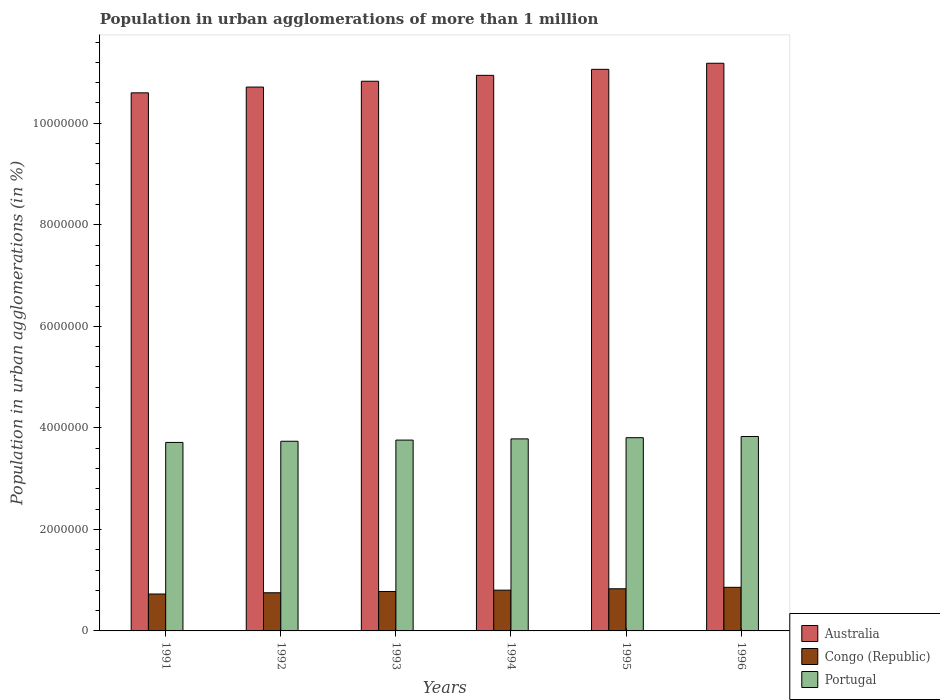How many different coloured bars are there?
Ensure brevity in your answer.  3. Are the number of bars per tick equal to the number of legend labels?
Offer a terse response. Yes. How many bars are there on the 3rd tick from the left?
Your answer should be very brief. 3. What is the label of the 4th group of bars from the left?
Offer a very short reply. 1994. In how many cases, is the number of bars for a given year not equal to the number of legend labels?
Give a very brief answer. 0. What is the population in urban agglomerations in Portugal in 1996?
Offer a terse response. 3.83e+06. Across all years, what is the maximum population in urban agglomerations in Portugal?
Provide a succinct answer. 3.83e+06. Across all years, what is the minimum population in urban agglomerations in Australia?
Provide a short and direct response. 1.06e+07. In which year was the population in urban agglomerations in Australia maximum?
Provide a succinct answer. 1996. In which year was the population in urban agglomerations in Australia minimum?
Give a very brief answer. 1991. What is the total population in urban agglomerations in Congo (Republic) in the graph?
Ensure brevity in your answer.  4.75e+06. What is the difference between the population in urban agglomerations in Australia in 1991 and that in 1992?
Offer a terse response. -1.14e+05. What is the difference between the population in urban agglomerations in Portugal in 1992 and the population in urban agglomerations in Australia in 1995?
Keep it short and to the point. -7.33e+06. What is the average population in urban agglomerations in Australia per year?
Offer a terse response. 1.09e+07. In the year 1993, what is the difference between the population in urban agglomerations in Australia and population in urban agglomerations in Congo (Republic)?
Give a very brief answer. 1.01e+07. What is the ratio of the population in urban agglomerations in Congo (Republic) in 1991 to that in 1995?
Your response must be concise. 0.88. Is the difference between the population in urban agglomerations in Australia in 1991 and 1996 greater than the difference between the population in urban agglomerations in Congo (Republic) in 1991 and 1996?
Your answer should be compact. No. What is the difference between the highest and the second highest population in urban agglomerations in Congo (Republic)?
Provide a succinct answer. 2.86e+04. What is the difference between the highest and the lowest population in urban agglomerations in Australia?
Your answer should be very brief. 5.83e+05. In how many years, is the population in urban agglomerations in Australia greater than the average population in urban agglomerations in Australia taken over all years?
Keep it short and to the point. 3. Is the sum of the population in urban agglomerations in Congo (Republic) in 1991 and 1992 greater than the maximum population in urban agglomerations in Australia across all years?
Make the answer very short. No. What does the 2nd bar from the left in 1996 represents?
Make the answer very short. Congo (Republic). What does the 2nd bar from the right in 1991 represents?
Provide a succinct answer. Congo (Republic). Are all the bars in the graph horizontal?
Provide a succinct answer. No. How many years are there in the graph?
Make the answer very short. 6. Are the values on the major ticks of Y-axis written in scientific E-notation?
Your answer should be compact. No. Does the graph contain any zero values?
Provide a succinct answer. No. Does the graph contain grids?
Your answer should be very brief. No. Where does the legend appear in the graph?
Ensure brevity in your answer.  Bottom right. How many legend labels are there?
Offer a terse response. 3. How are the legend labels stacked?
Make the answer very short. Vertical. What is the title of the graph?
Your response must be concise. Population in urban agglomerations of more than 1 million. Does "Uzbekistan" appear as one of the legend labels in the graph?
Give a very brief answer. No. What is the label or title of the X-axis?
Offer a terse response. Years. What is the label or title of the Y-axis?
Offer a terse response. Population in urban agglomerations (in %). What is the Population in urban agglomerations (in %) of Australia in 1991?
Provide a succinct answer. 1.06e+07. What is the Population in urban agglomerations (in %) in Congo (Republic) in 1991?
Your response must be concise. 7.27e+05. What is the Population in urban agglomerations (in %) of Portugal in 1991?
Offer a terse response. 3.71e+06. What is the Population in urban agglomerations (in %) in Australia in 1992?
Your answer should be very brief. 1.07e+07. What is the Population in urban agglomerations (in %) in Congo (Republic) in 1992?
Give a very brief answer. 7.52e+05. What is the Population in urban agglomerations (in %) in Portugal in 1992?
Provide a short and direct response. 3.74e+06. What is the Population in urban agglomerations (in %) of Australia in 1993?
Give a very brief answer. 1.08e+07. What is the Population in urban agglomerations (in %) of Congo (Republic) in 1993?
Ensure brevity in your answer.  7.77e+05. What is the Population in urban agglomerations (in %) in Portugal in 1993?
Your answer should be very brief. 3.76e+06. What is the Population in urban agglomerations (in %) in Australia in 1994?
Provide a short and direct response. 1.09e+07. What is the Population in urban agglomerations (in %) of Congo (Republic) in 1994?
Offer a terse response. 8.03e+05. What is the Population in urban agglomerations (in %) of Portugal in 1994?
Your response must be concise. 3.78e+06. What is the Population in urban agglomerations (in %) in Australia in 1995?
Make the answer very short. 1.11e+07. What is the Population in urban agglomerations (in %) in Congo (Republic) in 1995?
Keep it short and to the point. 8.30e+05. What is the Population in urban agglomerations (in %) of Portugal in 1995?
Your answer should be compact. 3.81e+06. What is the Population in urban agglomerations (in %) in Australia in 1996?
Provide a short and direct response. 1.12e+07. What is the Population in urban agglomerations (in %) in Congo (Republic) in 1996?
Keep it short and to the point. 8.59e+05. What is the Population in urban agglomerations (in %) in Portugal in 1996?
Your answer should be compact. 3.83e+06. Across all years, what is the maximum Population in urban agglomerations (in %) of Australia?
Make the answer very short. 1.12e+07. Across all years, what is the maximum Population in urban agglomerations (in %) in Congo (Republic)?
Provide a short and direct response. 8.59e+05. Across all years, what is the maximum Population in urban agglomerations (in %) of Portugal?
Make the answer very short. 3.83e+06. Across all years, what is the minimum Population in urban agglomerations (in %) in Australia?
Provide a short and direct response. 1.06e+07. Across all years, what is the minimum Population in urban agglomerations (in %) of Congo (Republic)?
Give a very brief answer. 7.27e+05. Across all years, what is the minimum Population in urban agglomerations (in %) in Portugal?
Provide a succinct answer. 3.71e+06. What is the total Population in urban agglomerations (in %) in Australia in the graph?
Your answer should be compact. 6.53e+07. What is the total Population in urban agglomerations (in %) in Congo (Republic) in the graph?
Provide a succinct answer. 4.75e+06. What is the total Population in urban agglomerations (in %) in Portugal in the graph?
Your answer should be very brief. 2.26e+07. What is the difference between the Population in urban agglomerations (in %) in Australia in 1991 and that in 1992?
Give a very brief answer. -1.14e+05. What is the difference between the Population in urban agglomerations (in %) in Congo (Republic) in 1991 and that in 1992?
Offer a very short reply. -2.45e+04. What is the difference between the Population in urban agglomerations (in %) in Portugal in 1991 and that in 1992?
Your answer should be compact. -2.31e+04. What is the difference between the Population in urban agglomerations (in %) in Australia in 1991 and that in 1993?
Provide a short and direct response. -2.28e+05. What is the difference between the Population in urban agglomerations (in %) in Congo (Republic) in 1991 and that in 1993?
Ensure brevity in your answer.  -4.98e+04. What is the difference between the Population in urban agglomerations (in %) of Portugal in 1991 and that in 1993?
Your response must be concise. -4.64e+04. What is the difference between the Population in urban agglomerations (in %) of Australia in 1991 and that in 1994?
Make the answer very short. -3.45e+05. What is the difference between the Population in urban agglomerations (in %) in Congo (Republic) in 1991 and that in 1994?
Give a very brief answer. -7.60e+04. What is the difference between the Population in urban agglomerations (in %) of Portugal in 1991 and that in 1994?
Provide a short and direct response. -6.98e+04. What is the difference between the Population in urban agglomerations (in %) of Australia in 1991 and that in 1995?
Ensure brevity in your answer.  -4.63e+05. What is the difference between the Population in urban agglomerations (in %) of Congo (Republic) in 1991 and that in 1995?
Ensure brevity in your answer.  -1.03e+05. What is the difference between the Population in urban agglomerations (in %) of Portugal in 1991 and that in 1995?
Provide a succinct answer. -9.33e+04. What is the difference between the Population in urban agglomerations (in %) of Australia in 1991 and that in 1996?
Provide a succinct answer. -5.83e+05. What is the difference between the Population in urban agglomerations (in %) of Congo (Republic) in 1991 and that in 1996?
Provide a succinct answer. -1.32e+05. What is the difference between the Population in urban agglomerations (in %) of Portugal in 1991 and that in 1996?
Give a very brief answer. -1.17e+05. What is the difference between the Population in urban agglomerations (in %) in Australia in 1992 and that in 1993?
Offer a very short reply. -1.15e+05. What is the difference between the Population in urban agglomerations (in %) in Congo (Republic) in 1992 and that in 1993?
Your answer should be very brief. -2.53e+04. What is the difference between the Population in urban agglomerations (in %) in Portugal in 1992 and that in 1993?
Provide a succinct answer. -2.32e+04. What is the difference between the Population in urban agglomerations (in %) of Australia in 1992 and that in 1994?
Provide a short and direct response. -2.31e+05. What is the difference between the Population in urban agglomerations (in %) in Congo (Republic) in 1992 and that in 1994?
Keep it short and to the point. -5.15e+04. What is the difference between the Population in urban agglomerations (in %) in Portugal in 1992 and that in 1994?
Provide a succinct answer. -4.66e+04. What is the difference between the Population in urban agglomerations (in %) in Australia in 1992 and that in 1995?
Your response must be concise. -3.49e+05. What is the difference between the Population in urban agglomerations (in %) in Congo (Republic) in 1992 and that in 1995?
Your answer should be very brief. -7.86e+04. What is the difference between the Population in urban agglomerations (in %) in Portugal in 1992 and that in 1995?
Your answer should be very brief. -7.02e+04. What is the difference between the Population in urban agglomerations (in %) in Australia in 1992 and that in 1996?
Offer a terse response. -4.69e+05. What is the difference between the Population in urban agglomerations (in %) in Congo (Republic) in 1992 and that in 1996?
Offer a very short reply. -1.07e+05. What is the difference between the Population in urban agglomerations (in %) of Portugal in 1992 and that in 1996?
Your response must be concise. -9.39e+04. What is the difference between the Population in urban agglomerations (in %) in Australia in 1993 and that in 1994?
Offer a very short reply. -1.16e+05. What is the difference between the Population in urban agglomerations (in %) in Congo (Republic) in 1993 and that in 1994?
Make the answer very short. -2.62e+04. What is the difference between the Population in urban agglomerations (in %) of Portugal in 1993 and that in 1994?
Provide a short and direct response. -2.34e+04. What is the difference between the Population in urban agglomerations (in %) in Australia in 1993 and that in 1995?
Provide a short and direct response. -2.34e+05. What is the difference between the Population in urban agglomerations (in %) in Congo (Republic) in 1993 and that in 1995?
Provide a succinct answer. -5.33e+04. What is the difference between the Population in urban agglomerations (in %) in Portugal in 1993 and that in 1995?
Give a very brief answer. -4.70e+04. What is the difference between the Population in urban agglomerations (in %) in Australia in 1993 and that in 1996?
Your response must be concise. -3.54e+05. What is the difference between the Population in urban agglomerations (in %) of Congo (Republic) in 1993 and that in 1996?
Give a very brief answer. -8.19e+04. What is the difference between the Population in urban agglomerations (in %) of Portugal in 1993 and that in 1996?
Provide a succinct answer. -7.07e+04. What is the difference between the Population in urban agglomerations (in %) in Australia in 1994 and that in 1995?
Provide a short and direct response. -1.18e+05. What is the difference between the Population in urban agglomerations (in %) of Congo (Republic) in 1994 and that in 1995?
Give a very brief answer. -2.71e+04. What is the difference between the Population in urban agglomerations (in %) of Portugal in 1994 and that in 1995?
Ensure brevity in your answer.  -2.36e+04. What is the difference between the Population in urban agglomerations (in %) in Australia in 1994 and that in 1996?
Your response must be concise. -2.38e+05. What is the difference between the Population in urban agglomerations (in %) of Congo (Republic) in 1994 and that in 1996?
Keep it short and to the point. -5.57e+04. What is the difference between the Population in urban agglomerations (in %) in Portugal in 1994 and that in 1996?
Your answer should be compact. -4.73e+04. What is the difference between the Population in urban agglomerations (in %) in Australia in 1995 and that in 1996?
Offer a very short reply. -1.20e+05. What is the difference between the Population in urban agglomerations (in %) in Congo (Republic) in 1995 and that in 1996?
Ensure brevity in your answer.  -2.86e+04. What is the difference between the Population in urban agglomerations (in %) of Portugal in 1995 and that in 1996?
Provide a short and direct response. -2.37e+04. What is the difference between the Population in urban agglomerations (in %) of Australia in 1991 and the Population in urban agglomerations (in %) of Congo (Republic) in 1992?
Offer a very short reply. 9.85e+06. What is the difference between the Population in urban agglomerations (in %) in Australia in 1991 and the Population in urban agglomerations (in %) in Portugal in 1992?
Make the answer very short. 6.86e+06. What is the difference between the Population in urban agglomerations (in %) of Congo (Republic) in 1991 and the Population in urban agglomerations (in %) of Portugal in 1992?
Your answer should be very brief. -3.01e+06. What is the difference between the Population in urban agglomerations (in %) of Australia in 1991 and the Population in urban agglomerations (in %) of Congo (Republic) in 1993?
Your answer should be very brief. 9.82e+06. What is the difference between the Population in urban agglomerations (in %) of Australia in 1991 and the Population in urban agglomerations (in %) of Portugal in 1993?
Provide a short and direct response. 6.84e+06. What is the difference between the Population in urban agglomerations (in %) in Congo (Republic) in 1991 and the Population in urban agglomerations (in %) in Portugal in 1993?
Offer a very short reply. -3.03e+06. What is the difference between the Population in urban agglomerations (in %) of Australia in 1991 and the Population in urban agglomerations (in %) of Congo (Republic) in 1994?
Give a very brief answer. 9.80e+06. What is the difference between the Population in urban agglomerations (in %) in Australia in 1991 and the Population in urban agglomerations (in %) in Portugal in 1994?
Keep it short and to the point. 6.82e+06. What is the difference between the Population in urban agglomerations (in %) of Congo (Republic) in 1991 and the Population in urban agglomerations (in %) of Portugal in 1994?
Your answer should be very brief. -3.06e+06. What is the difference between the Population in urban agglomerations (in %) of Australia in 1991 and the Population in urban agglomerations (in %) of Congo (Republic) in 1995?
Make the answer very short. 9.77e+06. What is the difference between the Population in urban agglomerations (in %) of Australia in 1991 and the Population in urban agglomerations (in %) of Portugal in 1995?
Your response must be concise. 6.79e+06. What is the difference between the Population in urban agglomerations (in %) of Congo (Republic) in 1991 and the Population in urban agglomerations (in %) of Portugal in 1995?
Offer a very short reply. -3.08e+06. What is the difference between the Population in urban agglomerations (in %) of Australia in 1991 and the Population in urban agglomerations (in %) of Congo (Republic) in 1996?
Ensure brevity in your answer.  9.74e+06. What is the difference between the Population in urban agglomerations (in %) in Australia in 1991 and the Population in urban agglomerations (in %) in Portugal in 1996?
Your answer should be compact. 6.77e+06. What is the difference between the Population in urban agglomerations (in %) in Congo (Republic) in 1991 and the Population in urban agglomerations (in %) in Portugal in 1996?
Keep it short and to the point. -3.10e+06. What is the difference between the Population in urban agglomerations (in %) in Australia in 1992 and the Population in urban agglomerations (in %) in Congo (Republic) in 1993?
Your response must be concise. 9.94e+06. What is the difference between the Population in urban agglomerations (in %) of Australia in 1992 and the Population in urban agglomerations (in %) of Portugal in 1993?
Ensure brevity in your answer.  6.95e+06. What is the difference between the Population in urban agglomerations (in %) of Congo (Republic) in 1992 and the Population in urban agglomerations (in %) of Portugal in 1993?
Ensure brevity in your answer.  -3.01e+06. What is the difference between the Population in urban agglomerations (in %) of Australia in 1992 and the Population in urban agglomerations (in %) of Congo (Republic) in 1994?
Give a very brief answer. 9.91e+06. What is the difference between the Population in urban agglomerations (in %) in Australia in 1992 and the Population in urban agglomerations (in %) in Portugal in 1994?
Offer a terse response. 6.93e+06. What is the difference between the Population in urban agglomerations (in %) of Congo (Republic) in 1992 and the Population in urban agglomerations (in %) of Portugal in 1994?
Offer a terse response. -3.03e+06. What is the difference between the Population in urban agglomerations (in %) in Australia in 1992 and the Population in urban agglomerations (in %) in Congo (Republic) in 1995?
Make the answer very short. 9.88e+06. What is the difference between the Population in urban agglomerations (in %) in Australia in 1992 and the Population in urban agglomerations (in %) in Portugal in 1995?
Offer a terse response. 6.91e+06. What is the difference between the Population in urban agglomerations (in %) in Congo (Republic) in 1992 and the Population in urban agglomerations (in %) in Portugal in 1995?
Ensure brevity in your answer.  -3.05e+06. What is the difference between the Population in urban agglomerations (in %) in Australia in 1992 and the Population in urban agglomerations (in %) in Congo (Republic) in 1996?
Offer a terse response. 9.85e+06. What is the difference between the Population in urban agglomerations (in %) in Australia in 1992 and the Population in urban agglomerations (in %) in Portugal in 1996?
Keep it short and to the point. 6.88e+06. What is the difference between the Population in urban agglomerations (in %) of Congo (Republic) in 1992 and the Population in urban agglomerations (in %) of Portugal in 1996?
Provide a short and direct response. -3.08e+06. What is the difference between the Population in urban agglomerations (in %) in Australia in 1993 and the Population in urban agglomerations (in %) in Congo (Republic) in 1994?
Keep it short and to the point. 1.00e+07. What is the difference between the Population in urban agglomerations (in %) in Australia in 1993 and the Population in urban agglomerations (in %) in Portugal in 1994?
Provide a succinct answer. 7.05e+06. What is the difference between the Population in urban agglomerations (in %) in Congo (Republic) in 1993 and the Population in urban agglomerations (in %) in Portugal in 1994?
Provide a short and direct response. -3.01e+06. What is the difference between the Population in urban agglomerations (in %) in Australia in 1993 and the Population in urban agglomerations (in %) in Congo (Republic) in 1995?
Offer a terse response. 1.00e+07. What is the difference between the Population in urban agglomerations (in %) of Australia in 1993 and the Population in urban agglomerations (in %) of Portugal in 1995?
Ensure brevity in your answer.  7.02e+06. What is the difference between the Population in urban agglomerations (in %) in Congo (Republic) in 1993 and the Population in urban agglomerations (in %) in Portugal in 1995?
Keep it short and to the point. -3.03e+06. What is the difference between the Population in urban agglomerations (in %) of Australia in 1993 and the Population in urban agglomerations (in %) of Congo (Republic) in 1996?
Make the answer very short. 9.97e+06. What is the difference between the Population in urban agglomerations (in %) in Australia in 1993 and the Population in urban agglomerations (in %) in Portugal in 1996?
Provide a succinct answer. 7.00e+06. What is the difference between the Population in urban agglomerations (in %) of Congo (Republic) in 1993 and the Population in urban agglomerations (in %) of Portugal in 1996?
Your answer should be very brief. -3.05e+06. What is the difference between the Population in urban agglomerations (in %) of Australia in 1994 and the Population in urban agglomerations (in %) of Congo (Republic) in 1995?
Offer a terse response. 1.01e+07. What is the difference between the Population in urban agglomerations (in %) of Australia in 1994 and the Population in urban agglomerations (in %) of Portugal in 1995?
Keep it short and to the point. 7.14e+06. What is the difference between the Population in urban agglomerations (in %) of Congo (Republic) in 1994 and the Population in urban agglomerations (in %) of Portugal in 1995?
Provide a short and direct response. -3.00e+06. What is the difference between the Population in urban agglomerations (in %) of Australia in 1994 and the Population in urban agglomerations (in %) of Congo (Republic) in 1996?
Provide a succinct answer. 1.01e+07. What is the difference between the Population in urban agglomerations (in %) of Australia in 1994 and the Population in urban agglomerations (in %) of Portugal in 1996?
Your answer should be compact. 7.11e+06. What is the difference between the Population in urban agglomerations (in %) in Congo (Republic) in 1994 and the Population in urban agglomerations (in %) in Portugal in 1996?
Make the answer very short. -3.03e+06. What is the difference between the Population in urban agglomerations (in %) of Australia in 1995 and the Population in urban agglomerations (in %) of Congo (Republic) in 1996?
Ensure brevity in your answer.  1.02e+07. What is the difference between the Population in urban agglomerations (in %) in Australia in 1995 and the Population in urban agglomerations (in %) in Portugal in 1996?
Keep it short and to the point. 7.23e+06. What is the difference between the Population in urban agglomerations (in %) in Congo (Republic) in 1995 and the Population in urban agglomerations (in %) in Portugal in 1996?
Your response must be concise. -3.00e+06. What is the average Population in urban agglomerations (in %) in Australia per year?
Provide a short and direct response. 1.09e+07. What is the average Population in urban agglomerations (in %) of Congo (Republic) per year?
Provide a succinct answer. 7.91e+05. What is the average Population in urban agglomerations (in %) of Portugal per year?
Your answer should be very brief. 3.77e+06. In the year 1991, what is the difference between the Population in urban agglomerations (in %) in Australia and Population in urban agglomerations (in %) in Congo (Republic)?
Offer a very short reply. 9.87e+06. In the year 1991, what is the difference between the Population in urban agglomerations (in %) of Australia and Population in urban agglomerations (in %) of Portugal?
Ensure brevity in your answer.  6.89e+06. In the year 1991, what is the difference between the Population in urban agglomerations (in %) of Congo (Republic) and Population in urban agglomerations (in %) of Portugal?
Keep it short and to the point. -2.99e+06. In the year 1992, what is the difference between the Population in urban agglomerations (in %) in Australia and Population in urban agglomerations (in %) in Congo (Republic)?
Your answer should be very brief. 9.96e+06. In the year 1992, what is the difference between the Population in urban agglomerations (in %) of Australia and Population in urban agglomerations (in %) of Portugal?
Make the answer very short. 6.98e+06. In the year 1992, what is the difference between the Population in urban agglomerations (in %) of Congo (Republic) and Population in urban agglomerations (in %) of Portugal?
Ensure brevity in your answer.  -2.98e+06. In the year 1993, what is the difference between the Population in urban agglomerations (in %) in Australia and Population in urban agglomerations (in %) in Congo (Republic)?
Provide a short and direct response. 1.01e+07. In the year 1993, what is the difference between the Population in urban agglomerations (in %) of Australia and Population in urban agglomerations (in %) of Portugal?
Give a very brief answer. 7.07e+06. In the year 1993, what is the difference between the Population in urban agglomerations (in %) of Congo (Republic) and Population in urban agglomerations (in %) of Portugal?
Ensure brevity in your answer.  -2.98e+06. In the year 1994, what is the difference between the Population in urban agglomerations (in %) in Australia and Population in urban agglomerations (in %) in Congo (Republic)?
Ensure brevity in your answer.  1.01e+07. In the year 1994, what is the difference between the Population in urban agglomerations (in %) of Australia and Population in urban agglomerations (in %) of Portugal?
Give a very brief answer. 7.16e+06. In the year 1994, what is the difference between the Population in urban agglomerations (in %) of Congo (Republic) and Population in urban agglomerations (in %) of Portugal?
Your answer should be very brief. -2.98e+06. In the year 1995, what is the difference between the Population in urban agglomerations (in %) of Australia and Population in urban agglomerations (in %) of Congo (Republic)?
Keep it short and to the point. 1.02e+07. In the year 1995, what is the difference between the Population in urban agglomerations (in %) in Australia and Population in urban agglomerations (in %) in Portugal?
Offer a very short reply. 7.26e+06. In the year 1995, what is the difference between the Population in urban agglomerations (in %) of Congo (Republic) and Population in urban agglomerations (in %) of Portugal?
Make the answer very short. -2.98e+06. In the year 1996, what is the difference between the Population in urban agglomerations (in %) of Australia and Population in urban agglomerations (in %) of Congo (Republic)?
Give a very brief answer. 1.03e+07. In the year 1996, what is the difference between the Population in urban agglomerations (in %) of Australia and Population in urban agglomerations (in %) of Portugal?
Ensure brevity in your answer.  7.35e+06. In the year 1996, what is the difference between the Population in urban agglomerations (in %) of Congo (Republic) and Population in urban agglomerations (in %) of Portugal?
Offer a terse response. -2.97e+06. What is the ratio of the Population in urban agglomerations (in %) of Congo (Republic) in 1991 to that in 1992?
Provide a short and direct response. 0.97. What is the ratio of the Population in urban agglomerations (in %) in Australia in 1991 to that in 1993?
Keep it short and to the point. 0.98. What is the ratio of the Population in urban agglomerations (in %) of Congo (Republic) in 1991 to that in 1993?
Your answer should be compact. 0.94. What is the ratio of the Population in urban agglomerations (in %) of Portugal in 1991 to that in 1993?
Offer a terse response. 0.99. What is the ratio of the Population in urban agglomerations (in %) of Australia in 1991 to that in 1994?
Give a very brief answer. 0.97. What is the ratio of the Population in urban agglomerations (in %) of Congo (Republic) in 1991 to that in 1994?
Give a very brief answer. 0.91. What is the ratio of the Population in urban agglomerations (in %) in Portugal in 1991 to that in 1994?
Provide a short and direct response. 0.98. What is the ratio of the Population in urban agglomerations (in %) in Australia in 1991 to that in 1995?
Give a very brief answer. 0.96. What is the ratio of the Population in urban agglomerations (in %) in Congo (Republic) in 1991 to that in 1995?
Make the answer very short. 0.88. What is the ratio of the Population in urban agglomerations (in %) of Portugal in 1991 to that in 1995?
Offer a very short reply. 0.98. What is the ratio of the Population in urban agglomerations (in %) in Australia in 1991 to that in 1996?
Your answer should be very brief. 0.95. What is the ratio of the Population in urban agglomerations (in %) in Congo (Republic) in 1991 to that in 1996?
Your answer should be very brief. 0.85. What is the ratio of the Population in urban agglomerations (in %) in Portugal in 1991 to that in 1996?
Your answer should be compact. 0.97. What is the ratio of the Population in urban agglomerations (in %) of Australia in 1992 to that in 1993?
Provide a short and direct response. 0.99. What is the ratio of the Population in urban agglomerations (in %) of Congo (Republic) in 1992 to that in 1993?
Provide a short and direct response. 0.97. What is the ratio of the Population in urban agglomerations (in %) in Portugal in 1992 to that in 1993?
Keep it short and to the point. 0.99. What is the ratio of the Population in urban agglomerations (in %) of Australia in 1992 to that in 1994?
Provide a succinct answer. 0.98. What is the ratio of the Population in urban agglomerations (in %) of Congo (Republic) in 1992 to that in 1994?
Ensure brevity in your answer.  0.94. What is the ratio of the Population in urban agglomerations (in %) of Portugal in 1992 to that in 1994?
Give a very brief answer. 0.99. What is the ratio of the Population in urban agglomerations (in %) of Australia in 1992 to that in 1995?
Your answer should be compact. 0.97. What is the ratio of the Population in urban agglomerations (in %) in Congo (Republic) in 1992 to that in 1995?
Your answer should be very brief. 0.91. What is the ratio of the Population in urban agglomerations (in %) in Portugal in 1992 to that in 1995?
Give a very brief answer. 0.98. What is the ratio of the Population in urban agglomerations (in %) of Australia in 1992 to that in 1996?
Give a very brief answer. 0.96. What is the ratio of the Population in urban agglomerations (in %) of Congo (Republic) in 1992 to that in 1996?
Provide a succinct answer. 0.88. What is the ratio of the Population in urban agglomerations (in %) in Portugal in 1992 to that in 1996?
Offer a very short reply. 0.98. What is the ratio of the Population in urban agglomerations (in %) of Congo (Republic) in 1993 to that in 1994?
Provide a succinct answer. 0.97. What is the ratio of the Population in urban agglomerations (in %) in Australia in 1993 to that in 1995?
Provide a succinct answer. 0.98. What is the ratio of the Population in urban agglomerations (in %) of Congo (Republic) in 1993 to that in 1995?
Give a very brief answer. 0.94. What is the ratio of the Population in urban agglomerations (in %) in Australia in 1993 to that in 1996?
Your response must be concise. 0.97. What is the ratio of the Population in urban agglomerations (in %) of Congo (Republic) in 1993 to that in 1996?
Provide a succinct answer. 0.9. What is the ratio of the Population in urban agglomerations (in %) in Portugal in 1993 to that in 1996?
Make the answer very short. 0.98. What is the ratio of the Population in urban agglomerations (in %) of Australia in 1994 to that in 1995?
Your answer should be compact. 0.99. What is the ratio of the Population in urban agglomerations (in %) in Congo (Republic) in 1994 to that in 1995?
Offer a very short reply. 0.97. What is the ratio of the Population in urban agglomerations (in %) of Portugal in 1994 to that in 1995?
Make the answer very short. 0.99. What is the ratio of the Population in urban agglomerations (in %) of Australia in 1994 to that in 1996?
Ensure brevity in your answer.  0.98. What is the ratio of the Population in urban agglomerations (in %) in Congo (Republic) in 1994 to that in 1996?
Your answer should be compact. 0.94. What is the ratio of the Population in urban agglomerations (in %) of Portugal in 1994 to that in 1996?
Keep it short and to the point. 0.99. What is the ratio of the Population in urban agglomerations (in %) of Australia in 1995 to that in 1996?
Give a very brief answer. 0.99. What is the ratio of the Population in urban agglomerations (in %) in Congo (Republic) in 1995 to that in 1996?
Offer a terse response. 0.97. What is the ratio of the Population in urban agglomerations (in %) of Portugal in 1995 to that in 1996?
Give a very brief answer. 0.99. What is the difference between the highest and the second highest Population in urban agglomerations (in %) of Australia?
Your answer should be compact. 1.20e+05. What is the difference between the highest and the second highest Population in urban agglomerations (in %) of Congo (Republic)?
Your answer should be compact. 2.86e+04. What is the difference between the highest and the second highest Population in urban agglomerations (in %) in Portugal?
Offer a terse response. 2.37e+04. What is the difference between the highest and the lowest Population in urban agglomerations (in %) of Australia?
Provide a short and direct response. 5.83e+05. What is the difference between the highest and the lowest Population in urban agglomerations (in %) of Congo (Republic)?
Give a very brief answer. 1.32e+05. What is the difference between the highest and the lowest Population in urban agglomerations (in %) of Portugal?
Your answer should be compact. 1.17e+05. 